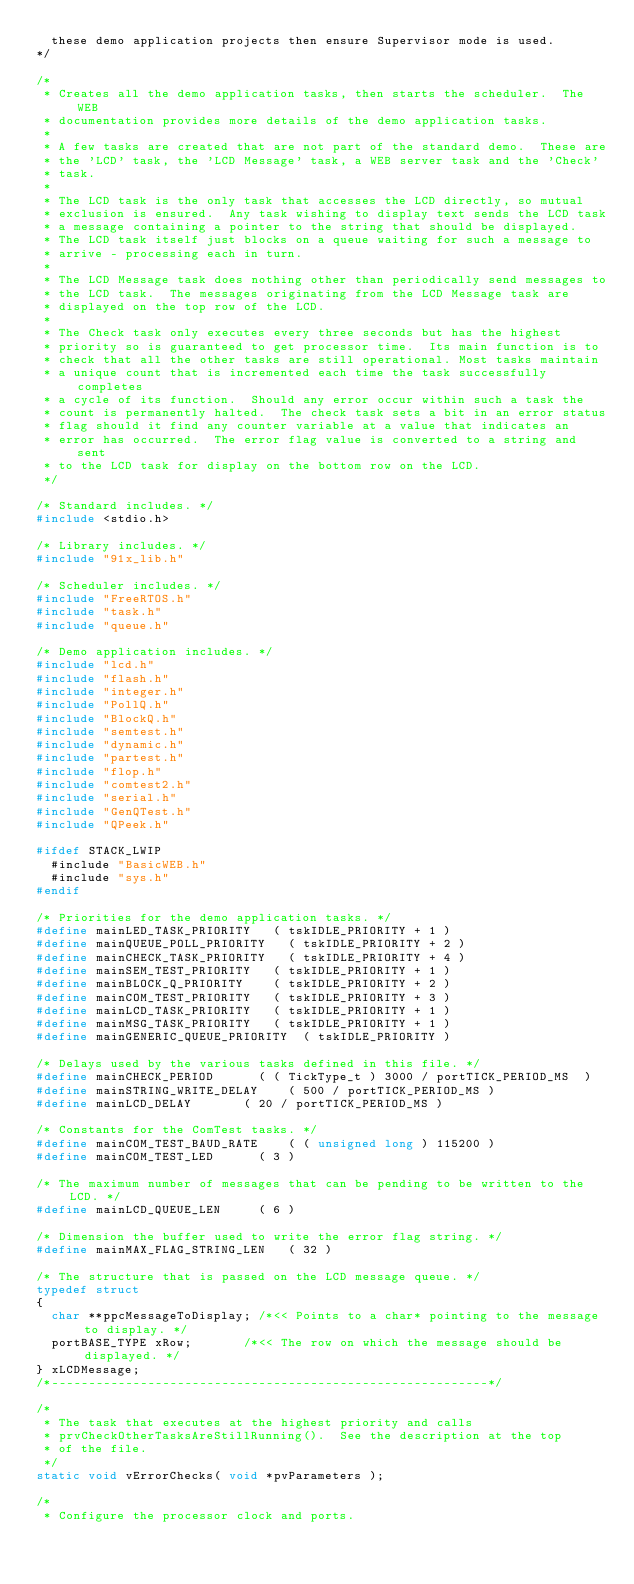<code> <loc_0><loc_0><loc_500><loc_500><_C_>	these demo application projects then ensure Supervisor mode is used.
*/

/*
 * Creates all the demo application tasks, then starts the scheduler.  The WEB
 * documentation provides more details of the demo application tasks.
 *
 * A few tasks are created that are not part of the standard demo.  These are
 * the 'LCD' task, the 'LCD Message' task, a WEB server task and the 'Check'
 * task.
 *
 * The LCD task is the only task that accesses the LCD directly, so mutual
 * exclusion is ensured.  Any task wishing to display text sends the LCD task
 * a message containing a pointer to the string that should be displayed.
 * The LCD task itself just blocks on a queue waiting for such a message to
 * arrive - processing each in turn.
 *
 * The LCD Message task does nothing other than periodically send messages to
 * the LCD task.  The messages originating from the LCD Message task are
 * displayed on the top row of the LCD.
 *
 * The Check task only executes every three seconds but has the highest
 * priority so is guaranteed to get processor time.  Its main function is to
 * check that all the other tasks are still operational. Most tasks maintain
 * a unique count that is incremented each time the task successfully completes
 * a cycle of its function.  Should any error occur within such a task the
 * count is permanently halted.  The check task sets a bit in an error status
 * flag should it find any counter variable at a value that indicates an
 * error has occurred.  The error flag value is converted to a string and sent
 * to the LCD task for display on the bottom row on the LCD.
 */

/* Standard includes. */
#include <stdio.h>

/* Library includes. */
#include "91x_lib.h"

/* Scheduler includes. */
#include "FreeRTOS.h"
#include "task.h"
#include "queue.h"

/* Demo application includes. */
#include "lcd.h"
#include "flash.h"
#include "integer.h"
#include "PollQ.h"
#include "BlockQ.h"
#include "semtest.h"
#include "dynamic.h"
#include "partest.h"
#include "flop.h"
#include "comtest2.h"
#include "serial.h"
#include "GenQTest.h"
#include "QPeek.h"

#ifdef STACK_LWIP
	#include "BasicWEB.h"
	#include "sys.h"
#endif

/* Priorities for the demo application tasks. */
#define mainLED_TASK_PRIORITY		( tskIDLE_PRIORITY + 1 )
#define mainQUEUE_POLL_PRIORITY		( tskIDLE_PRIORITY + 2 )
#define mainCHECK_TASK_PRIORITY		( tskIDLE_PRIORITY + 4 )
#define mainSEM_TEST_PRIORITY		( tskIDLE_PRIORITY + 1 )
#define mainBLOCK_Q_PRIORITY		( tskIDLE_PRIORITY + 2 )
#define mainCOM_TEST_PRIORITY		( tskIDLE_PRIORITY + 3 )
#define mainLCD_TASK_PRIORITY		( tskIDLE_PRIORITY + 1 )
#define mainMSG_TASK_PRIORITY		( tskIDLE_PRIORITY + 1 )
#define mainGENERIC_QUEUE_PRIORITY	( tskIDLE_PRIORITY )

/* Delays used by the various tasks defined in this file. */
#define mainCHECK_PERIOD			( ( TickType_t ) 3000 / portTICK_PERIOD_MS  )
#define mainSTRING_WRITE_DELAY		( 500 / portTICK_PERIOD_MS )
#define mainLCD_DELAY				( 20 / portTICK_PERIOD_MS )

/* Constants for the ComTest tasks. */
#define mainCOM_TEST_BAUD_RATE		( ( unsigned long ) 115200 )
#define mainCOM_TEST_LED			( 3 )

/* The maximum number of messages that can be pending to be written to the LCD. */
#define mainLCD_QUEUE_LEN			( 6 )

/* Dimension the buffer used to write the error flag string. */
#define mainMAX_FLAG_STRING_LEN		( 32 )

/* The structure that is passed on the LCD message queue. */
typedef struct
{
	char **ppcMessageToDisplay; /*<< Points to a char* pointing to the message to display. */
	portBASE_TYPE xRow;				/*<< The row on which the message should be displayed. */
} xLCDMessage;
/*-----------------------------------------------------------*/

/*
 * The task that executes at the highest priority and calls
 * prvCheckOtherTasksAreStillRunning().  See the description at the top
 * of the file.
 */
static void vErrorChecks( void *pvParameters );

/*
 * Configure the processor clock and ports.</code> 